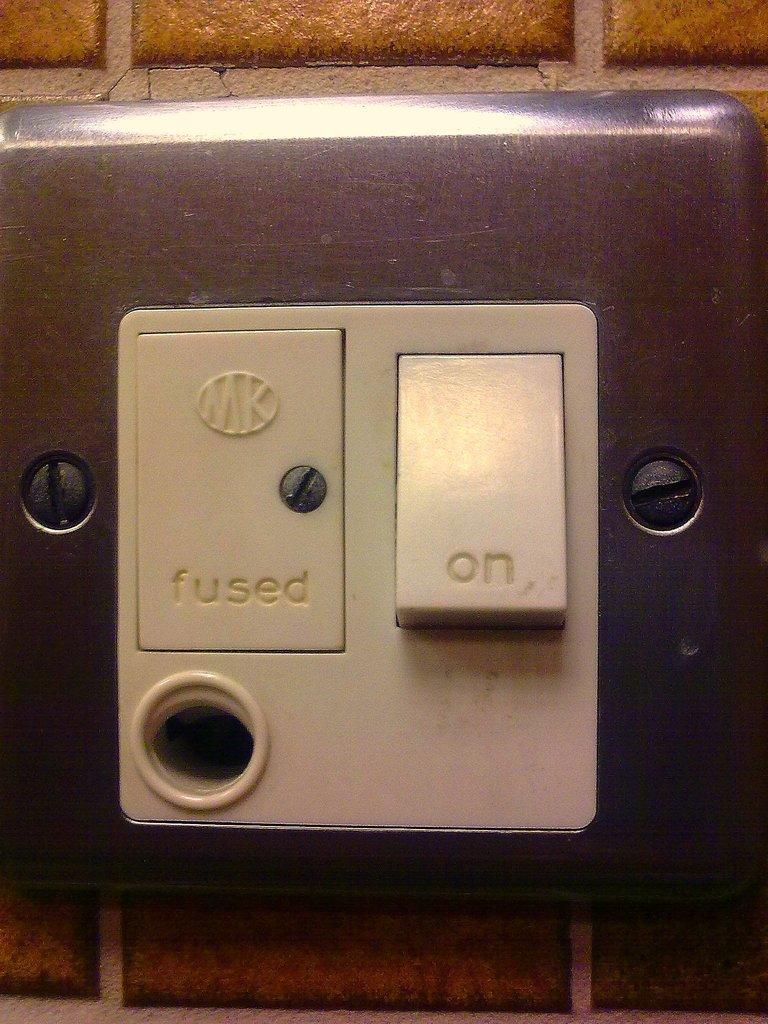<image>
Present a compact description of the photo's key features. a light switch that has the word fused on it 